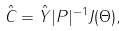<formula> <loc_0><loc_0><loc_500><loc_500>\hat { C } = \hat { Y } | P | ^ { - 1 } J ( \Theta ) ,</formula> 